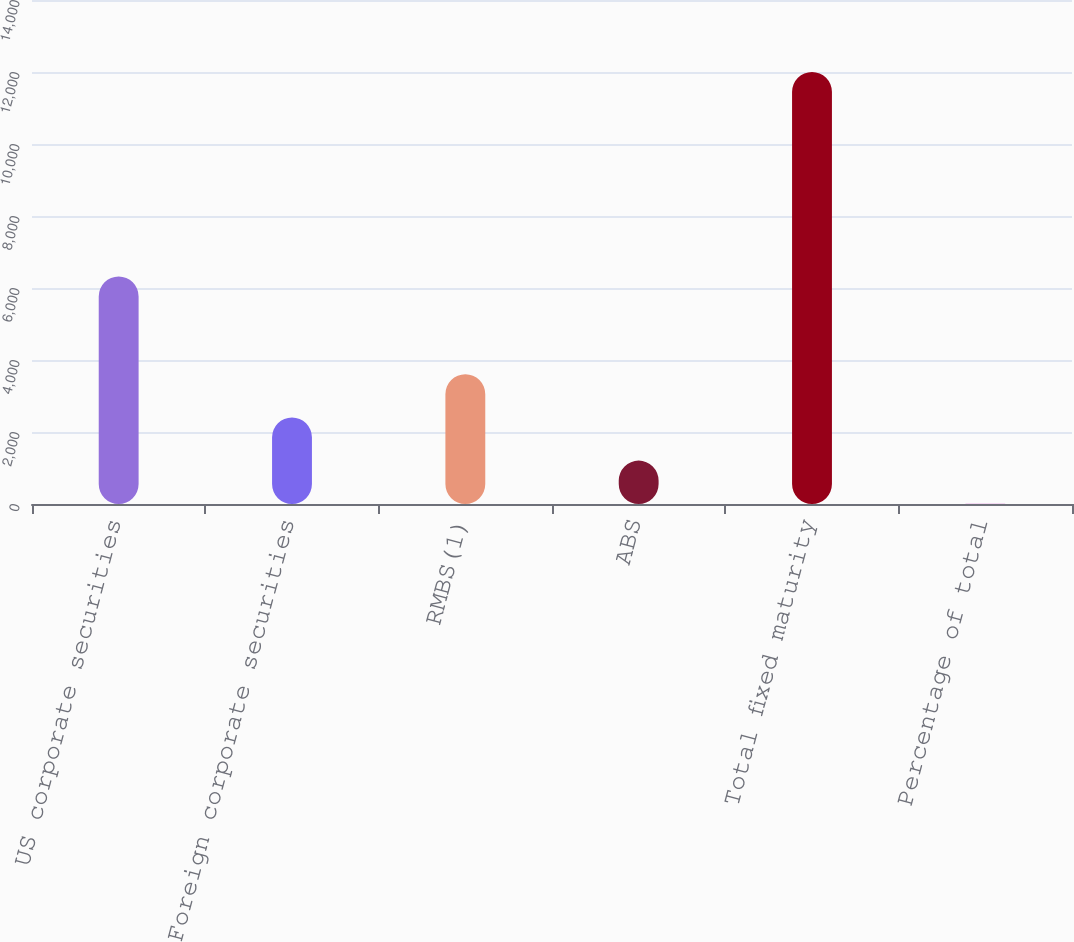<chart> <loc_0><loc_0><loc_500><loc_500><bar_chart><fcel>US corporate securities<fcel>Foreign corporate securities<fcel>RMBS(1)<fcel>ABS<fcel>Total fixed maturity<fcel>Percentage of total<nl><fcel>6319<fcel>2404.84<fcel>3604.61<fcel>1205.07<fcel>12003<fcel>5.3<nl></chart> 